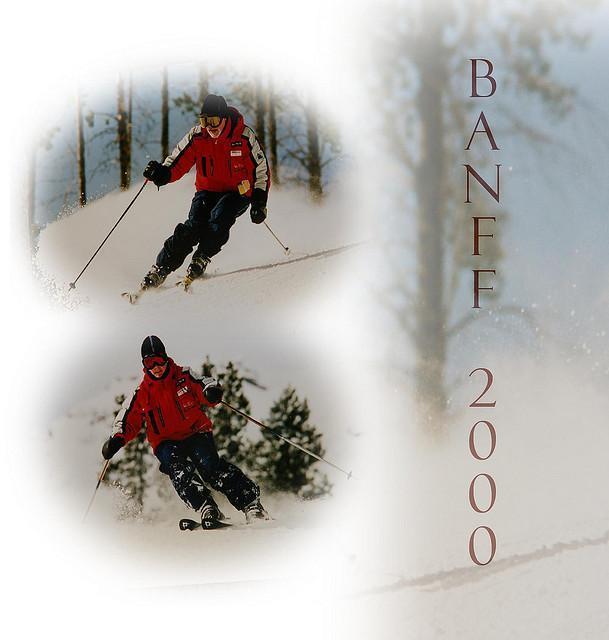How many people are in the photo?
Give a very brief answer. 2. How many white cars are on the road?
Give a very brief answer. 0. 